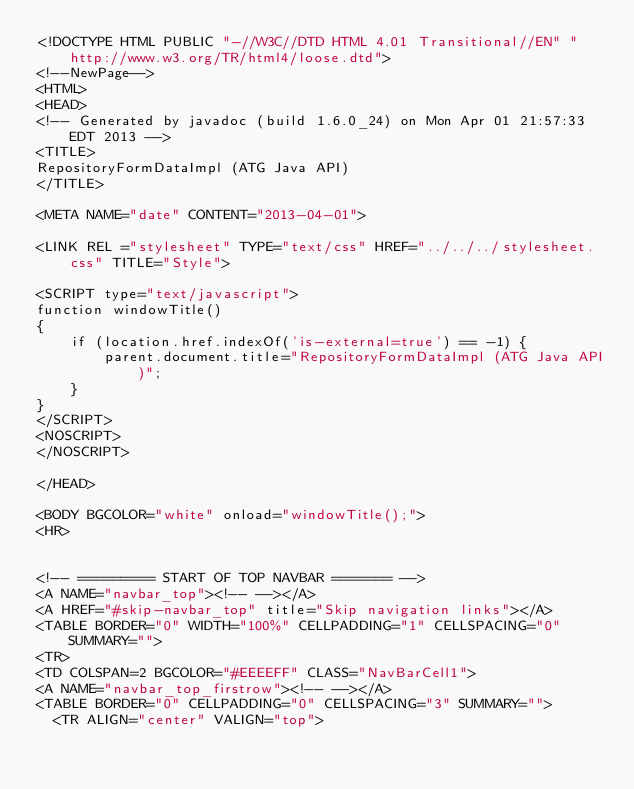Convert code to text. <code><loc_0><loc_0><loc_500><loc_500><_HTML_><!DOCTYPE HTML PUBLIC "-//W3C//DTD HTML 4.01 Transitional//EN" "http://www.w3.org/TR/html4/loose.dtd">
<!--NewPage-->
<HTML>
<HEAD>
<!-- Generated by javadoc (build 1.6.0_24) on Mon Apr 01 21:57:33 EDT 2013 -->
<TITLE>
RepositoryFormDataImpl (ATG Java API)
</TITLE>

<META NAME="date" CONTENT="2013-04-01">

<LINK REL ="stylesheet" TYPE="text/css" HREF="../../../stylesheet.css" TITLE="Style">

<SCRIPT type="text/javascript">
function windowTitle()
{
    if (location.href.indexOf('is-external=true') == -1) {
        parent.document.title="RepositoryFormDataImpl (ATG Java API)";
    }
}
</SCRIPT>
<NOSCRIPT>
</NOSCRIPT>

</HEAD>

<BODY BGCOLOR="white" onload="windowTitle();">
<HR>


<!-- ========= START OF TOP NAVBAR ======= -->
<A NAME="navbar_top"><!-- --></A>
<A HREF="#skip-navbar_top" title="Skip navigation links"></A>
<TABLE BORDER="0" WIDTH="100%" CELLPADDING="1" CELLSPACING="0" SUMMARY="">
<TR>
<TD COLSPAN=2 BGCOLOR="#EEEEFF" CLASS="NavBarCell1">
<A NAME="navbar_top_firstrow"><!-- --></A>
<TABLE BORDER="0" CELLPADDING="0" CELLSPACING="3" SUMMARY="">
  <TR ALIGN="center" VALIGN="top"></code> 